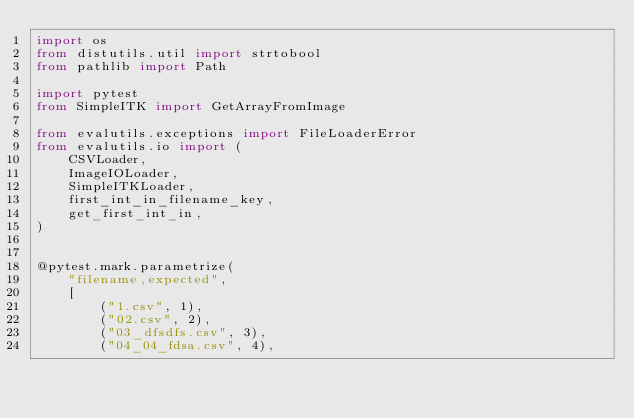Convert code to text. <code><loc_0><loc_0><loc_500><loc_500><_Python_>import os
from distutils.util import strtobool
from pathlib import Path

import pytest
from SimpleITK import GetArrayFromImage

from evalutils.exceptions import FileLoaderError
from evalutils.io import (
    CSVLoader,
    ImageIOLoader,
    SimpleITKLoader,
    first_int_in_filename_key,
    get_first_int_in,
)


@pytest.mark.parametrize(
    "filename,expected",
    [
        ("1.csv", 1),
        ("02.csv", 2),
        ("03_dfsdfs.csv", 3),
        ("04_04_fdsa.csv", 4),</code> 